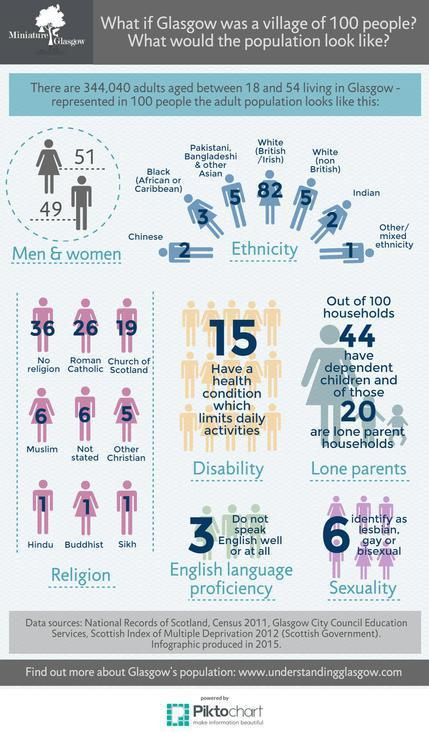List a handful of essential elements in this visual. Among the adults aged 18-54 years living in Glasgow, approximately 6% of the village of 100 people identified as lesbian, gay, or bisexual. Approximately 1 out of every 100 adult women aged 18-54 living in Glasgow is Hindu, if the population is represented as a village of 100 people. In a village of 100 people, 26 adult women aged 18-54 years living in Glasgow are Roman Catholic. In a village of 100 people in Glasgow, 82 of them are white adults aged 18-54 years who are British or Irish. In a village of 100 people in Glasgow, there are 51 adults aged 18-54 years who are women. 